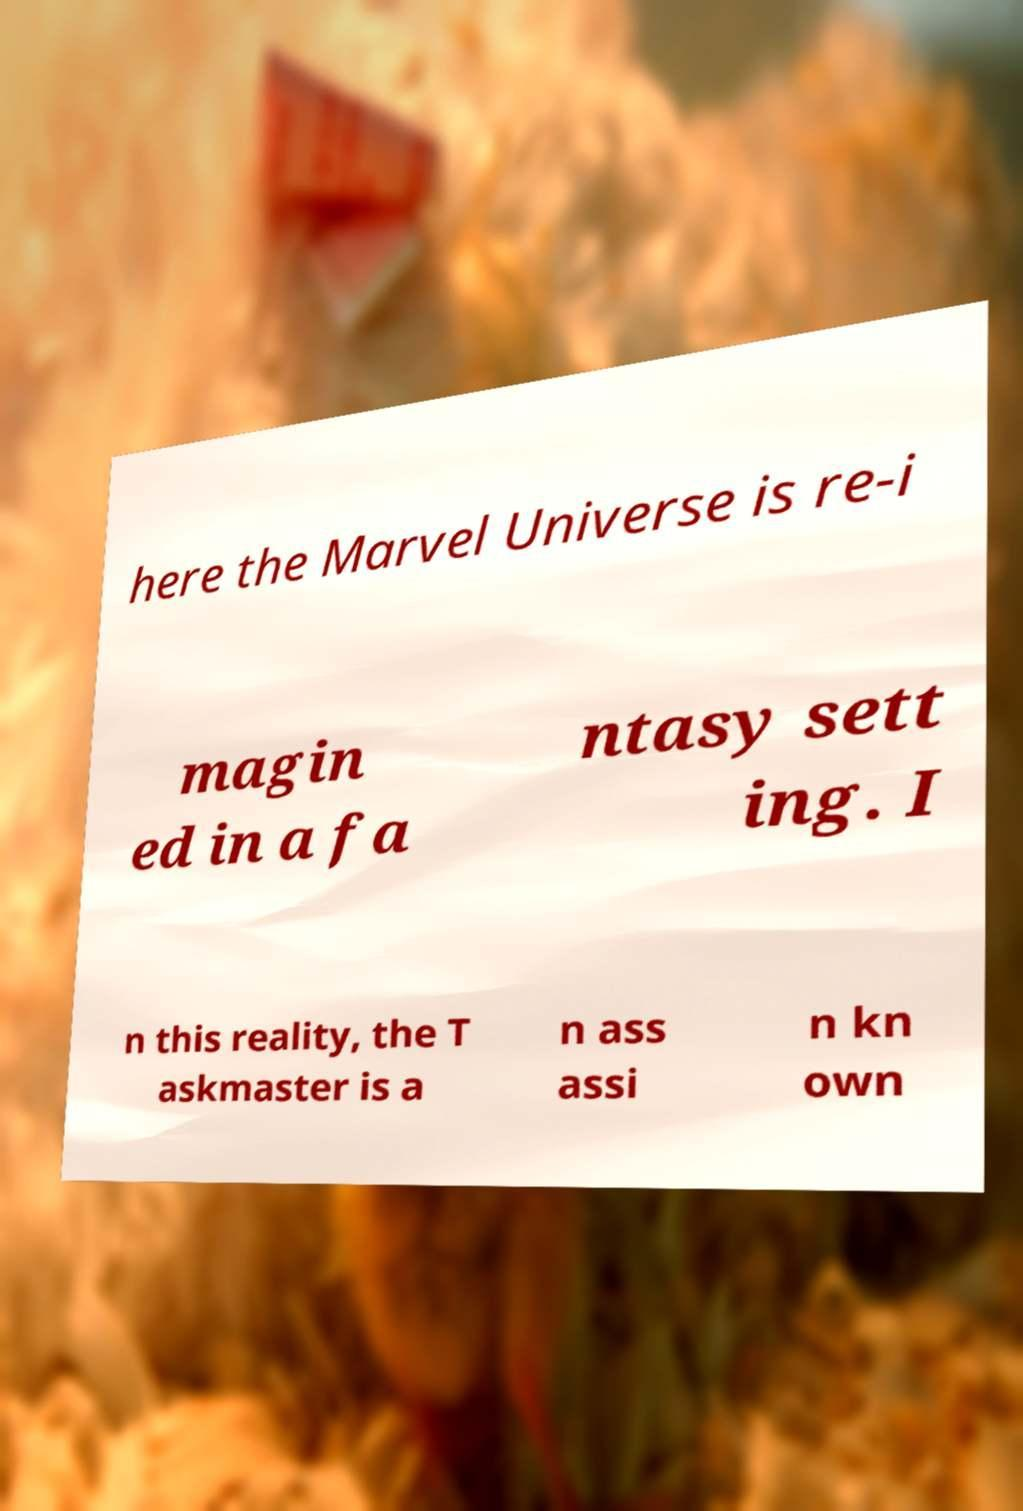Can you accurately transcribe the text from the provided image for me? here the Marvel Universe is re-i magin ed in a fa ntasy sett ing. I n this reality, the T askmaster is a n ass assi n kn own 